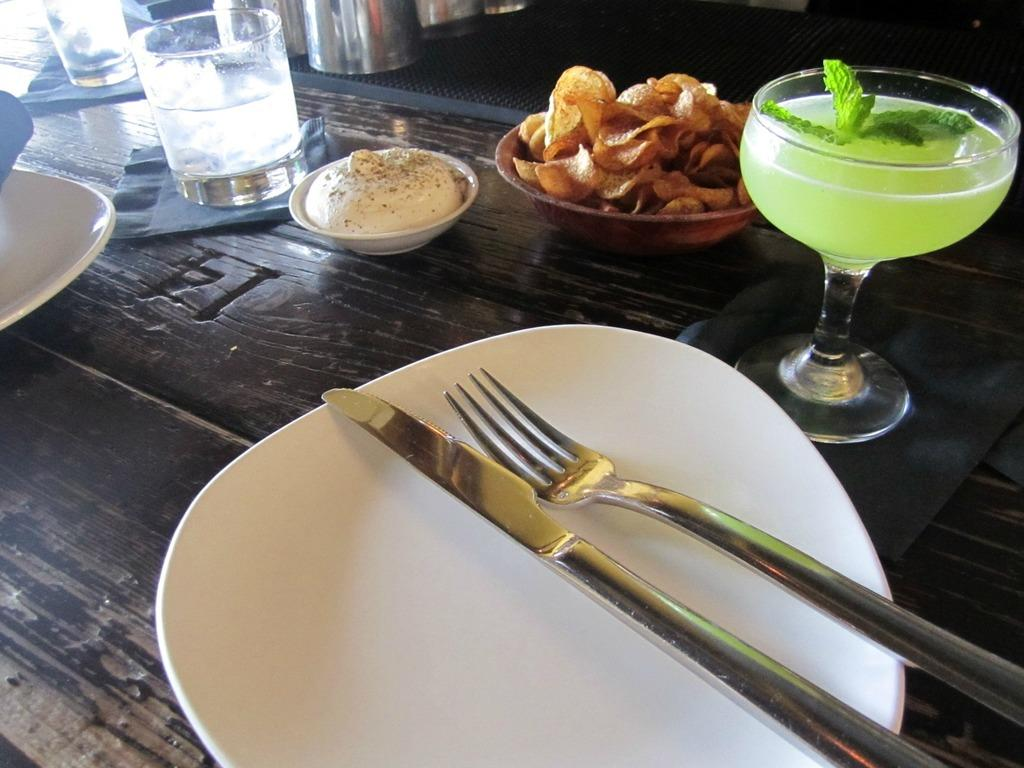What type of items can be seen on the table in the image? There are eatables, glasses, plates, forks, and spoons arranged on the table in the image. What might be used for drinking in the image? Glasses can be used for drinking in the image. What might be used for eating in the image? Forks and spoons can be used for eating in the image. What might be used for serving food in the image? Plates can be used for serving food in the image. What type of tongue can be seen in the image? There is no tongue present in the image. What type of apparatus is used for measuring angles in the image? There is no apparatus for measuring angles present in the image. 